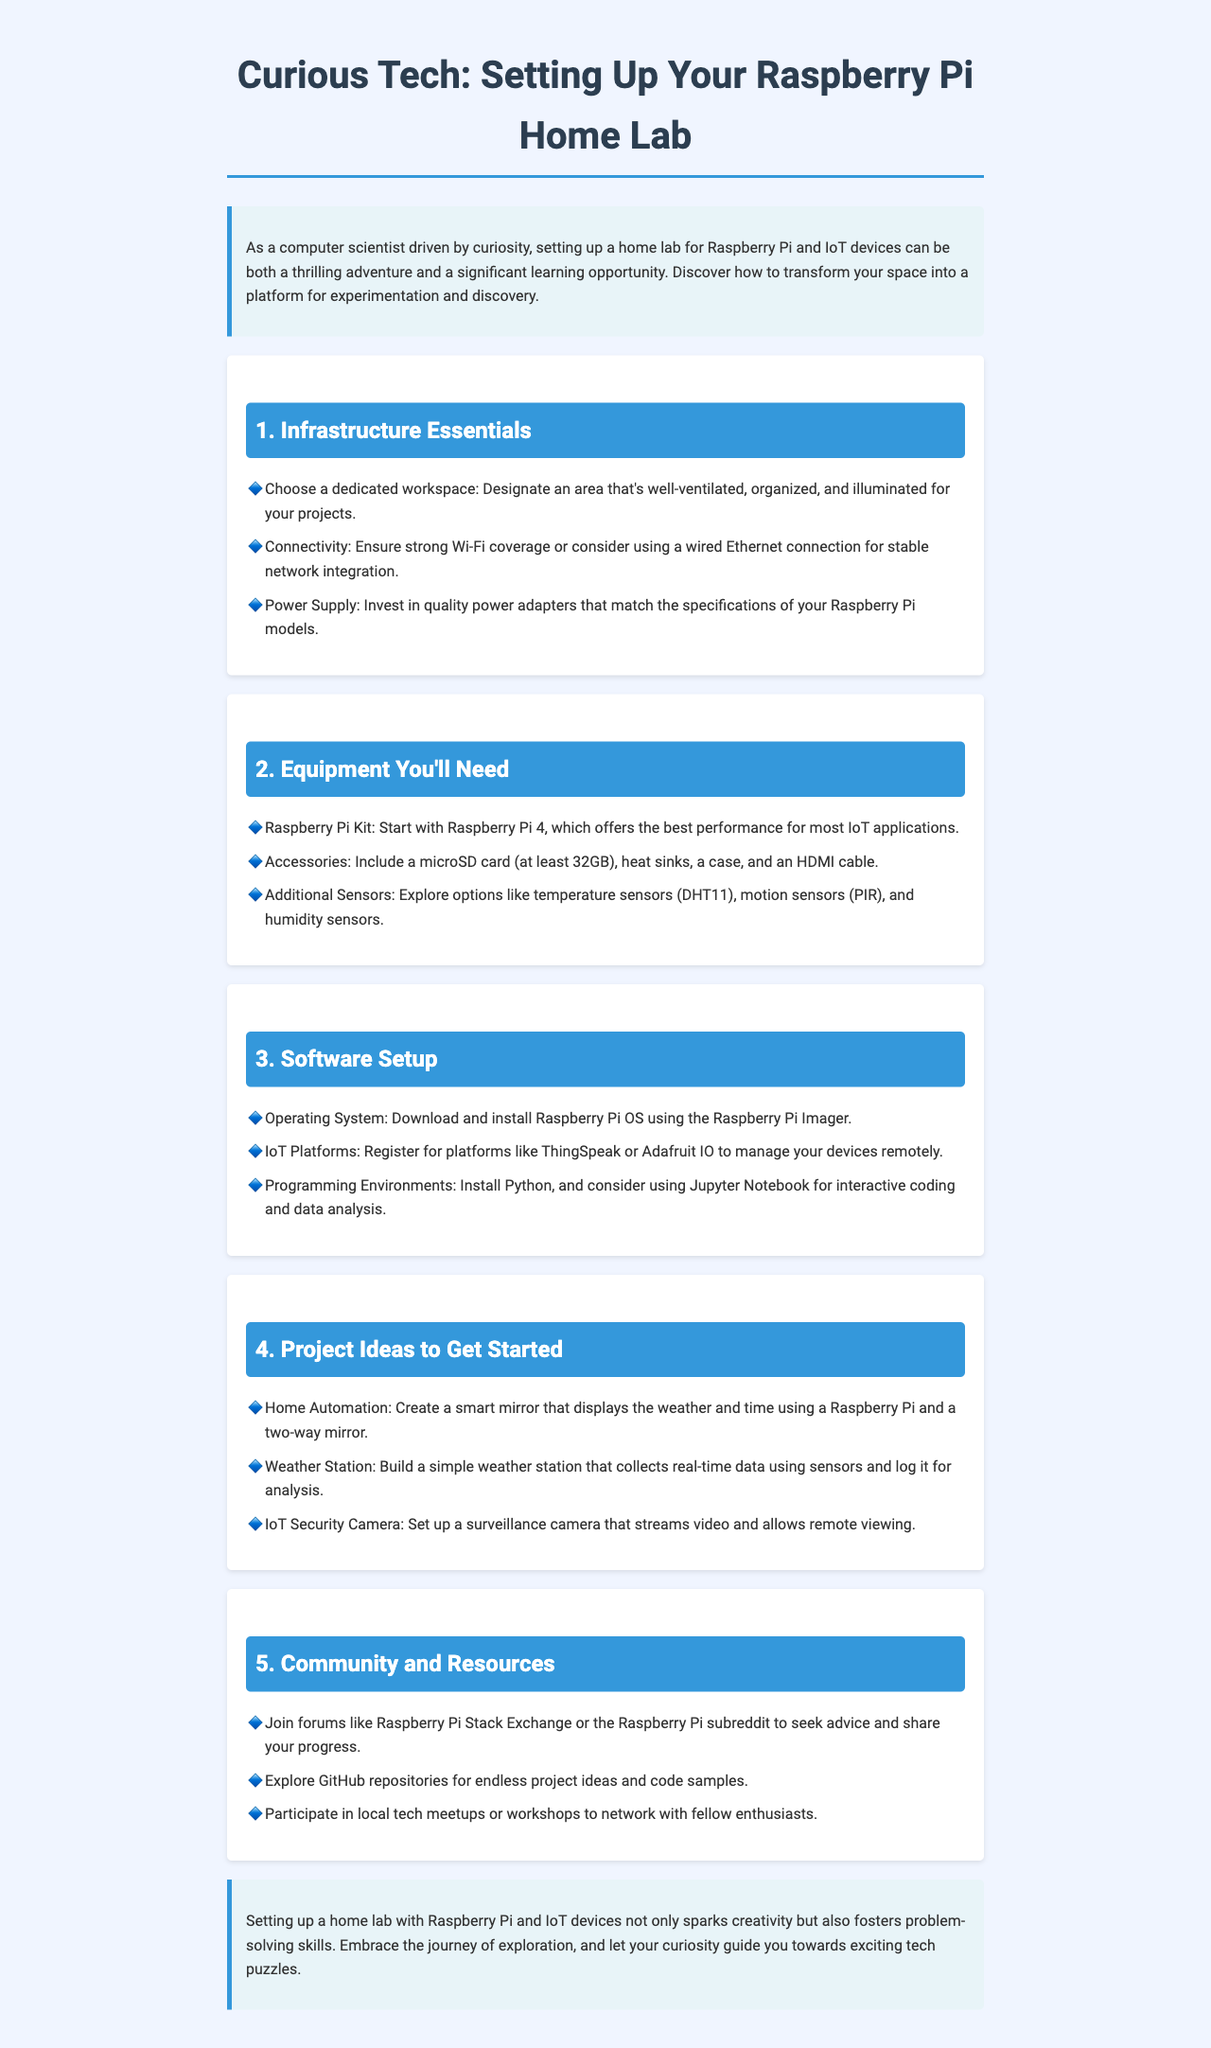What is the title of the newsletter? The title of the newsletter is provided in the header of the document.
Answer: Curious Tech: Setting Up Your Raspberry Pi Home Lab How many project ideas are listed in the document? The number of project ideas can be identified in the "Project Ideas to Get Started" section.
Answer: 3 Which Raspberry Pi model is recommended in the equipment section? The recommended Raspberry Pi model is mentioned in the "Equipment You'll Need" section.
Answer: Raspberry Pi 4 What should be installed for managing IoT devices remotely? The document specifies platforms that can be used to manage devices remotely in the "Software Setup" section.
Answer: ThingSpeak or Adafruit IO What type of sensor is mentioned for temperature measurement? The sensor type for temperature measurement is specified under the "Equipment You'll Need" section.
Answer: DHT11 What is emphasized at the end of the newsletter regarding setting up a home lab? The concluding remarks highlight the benefits of setting up a home lab based on the final thoughts in the document.
Answer: Creativity and problem-solving skills Which two types of sensors are listed as additional sensors to explore? The document mentions specific sensors in the "Equipment You'll Need" section.
Answer: Temperature sensors and motion sensors What is a suggested use for the Raspberry Pi in home automation? The document outlines a specific project idea related to home automation.
Answer: Smart mirror 